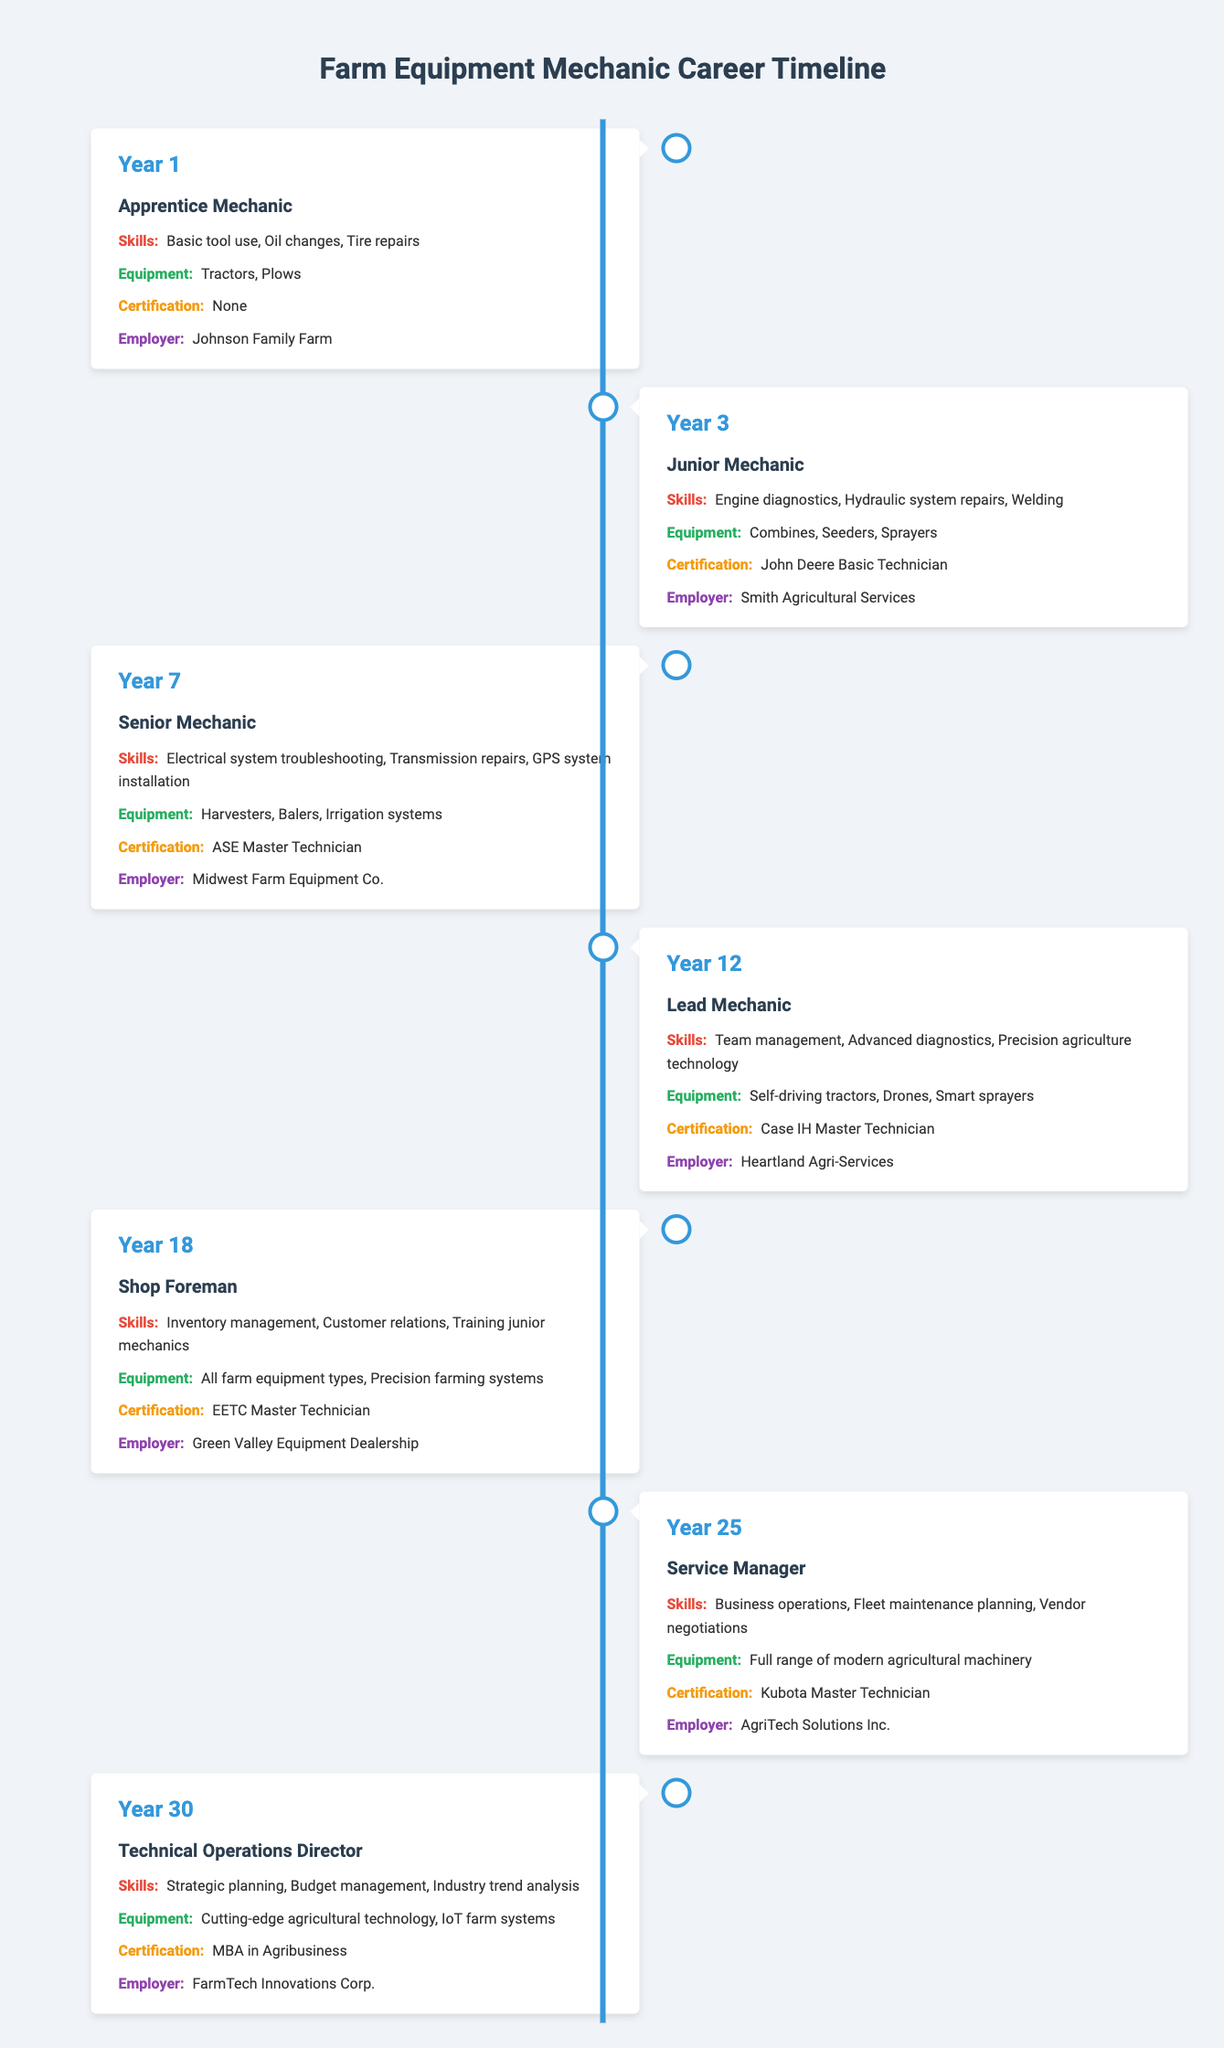What is the stage of a mechanic in year 3? The table lists the details for each year. For year 3, the stage is "Junior Mechanic."
Answer: Junior Mechanic How many years does it take to advance from Apprentice Mechanic to Service Manager? The mechanic starts as an "Apprentice Mechanic" in year 1 and is promoted to "Service Manager" in year 25. The difference is 25 - 1 = 24 years.
Answer: 24 years Does the Lead Mechanic have any certification? The table shows that the Lead Mechanic has the "Case IH Master Technician" certification. Therefore, the statement is true.
Answer: Yes What are the skills required for a Senior Mechanic? The table indicates that a Senior Mechanic needs skills in "Electrical system troubleshooting," "Transmission repairs," and "GPS system installation."
Answer: Electrical system troubleshooting, Transmission repairs, GPS system installation What is the average number of years between promotions from the Apprentice Mechanic stage to the Technical Operations Director stage? The advances occur at years 1, 3, 7, 12, 18, 25, and 30. There are six intervals: 3-1, 7-3, 12-7, 18-12, 25-18, and 30-25. These intervals are 2, 4, 5, 6, 7, and 5 years respectively. Summing these gives 29 years. Dividing by 6 intervals results in an average of 29/6 = 4.83 years.
Answer: 4.83 years Which employer does the Shop Foreman work for? According to the table, the Shop Foreman is employed by "Green Valley Equipment Dealership."
Answer: Green Valley Equipment Dealership How many different types of equipment does the Service Manager work with? The Service Manager works with "Full range of modern agricultural machinery," implying a wide variety rather than listing specific items. Therefore, it signifies many types but doesn't provide a specific count.
Answer: Full range of modern agricultural machinery True or False: The Junior Mechanic is certified as an ASE Master Technician. The table indicates that the Junior Mechanic holds a "John Deere Basic Technician" certification, not an ASE Master Technician. Therefore, the statement is false.
Answer: False What two pieces of equipment are associated with the Lead Mechanic? The Lead Mechanic works with "Self-driving tractors" and "Drones," according to the information in the table.
Answer: Self-driving tractors, Drones 